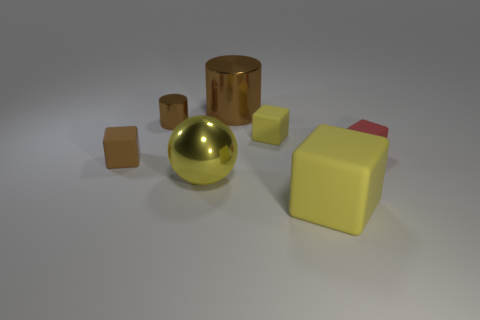Add 1 tiny cyan matte cylinders. How many objects exist? 8 Subtract all yellow blocks. How many blocks are left? 2 Subtract all red balls. Subtract all green cylinders. How many balls are left? 1 Subtract all brown balls. How many purple blocks are left? 0 Subtract all tiny yellow rubber balls. Subtract all tiny rubber objects. How many objects are left? 4 Add 1 large things. How many large things are left? 4 Add 7 big rubber objects. How many big rubber objects exist? 8 Subtract all red rubber cubes. How many cubes are left? 3 Subtract 0 purple blocks. How many objects are left? 7 Subtract all balls. How many objects are left? 6 